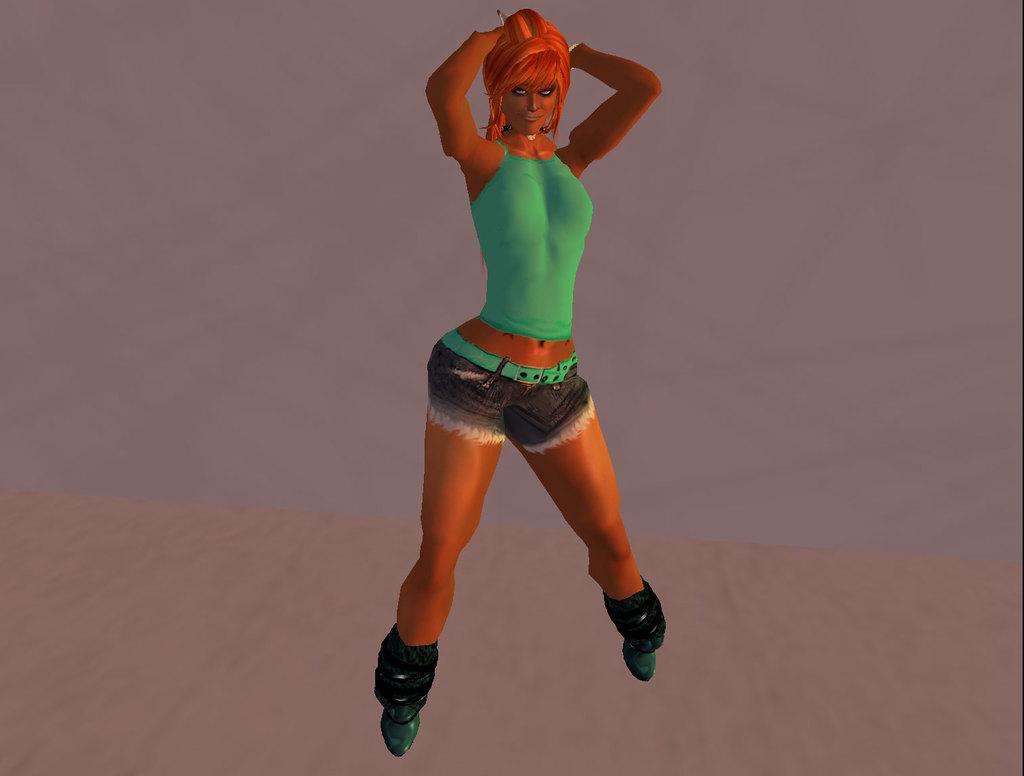What is the main subject of the image? There is a toy girl in the image. Where is the toy girl located in the image? The toy girl is standing on the floor. What is the toy girl wearing in the image? The toy girl is wearing a green color dress. What is the chance of the toy girl performing an operation in the image? There is no mention of an operation or any related context in the image, so it is not possible to determine the chance of the toy girl performing an operation. 